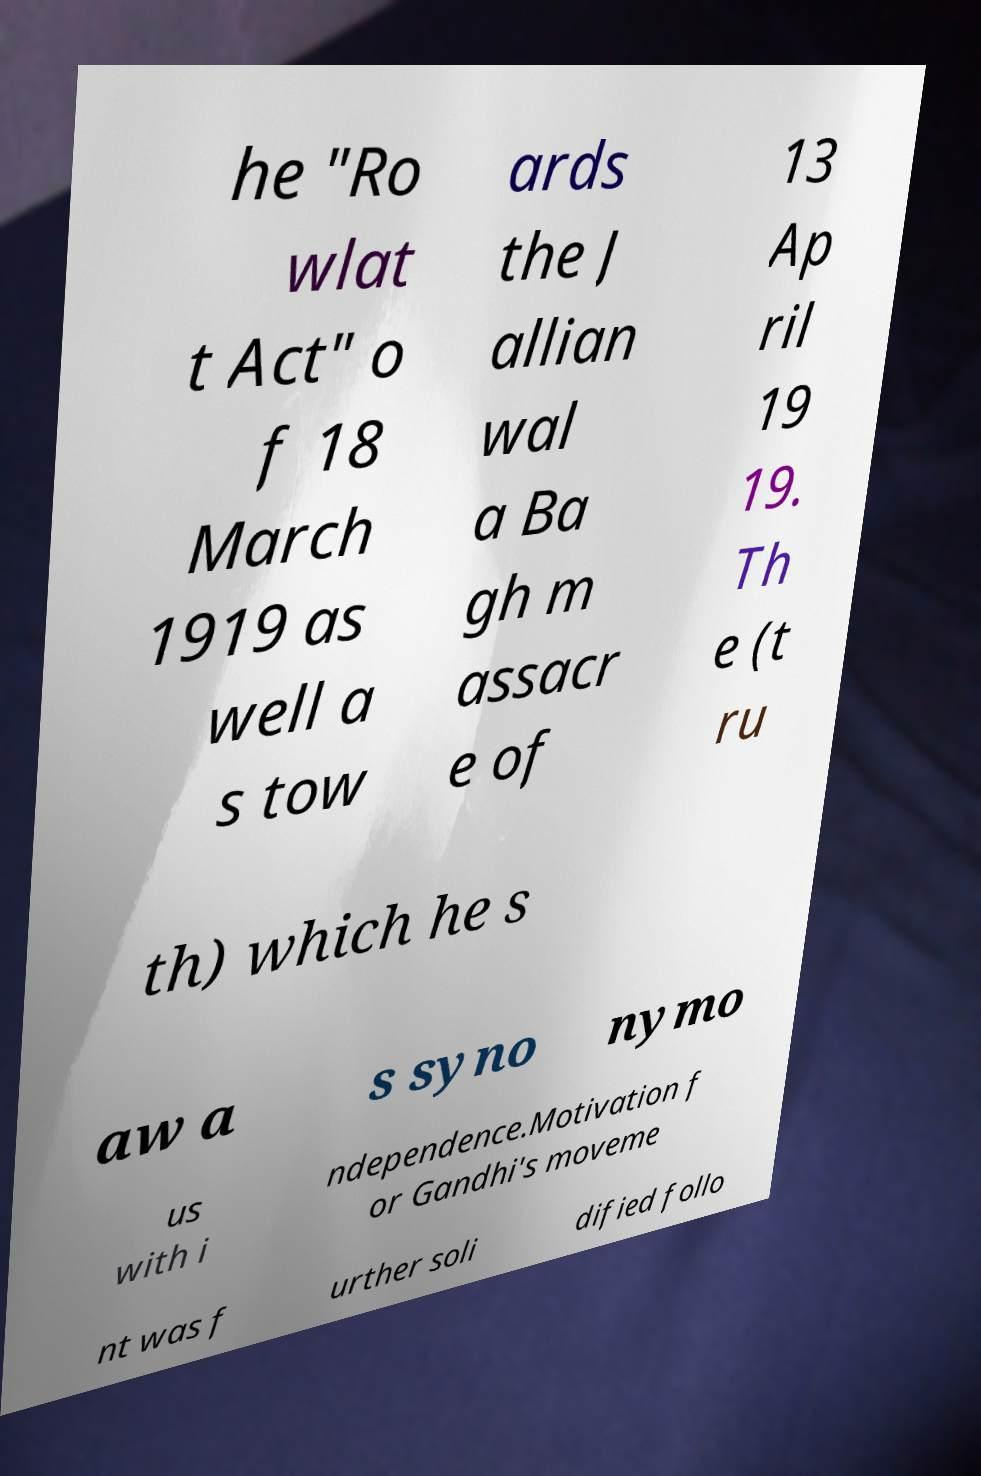I need the written content from this picture converted into text. Can you do that? he "Ro wlat t Act" o f 18 March 1919 as well a s tow ards the J allian wal a Ba gh m assacr e of 13 Ap ril 19 19. Th e (t ru th) which he s aw a s syno nymo us with i ndependence.Motivation f or Gandhi's moveme nt was f urther soli dified follo 